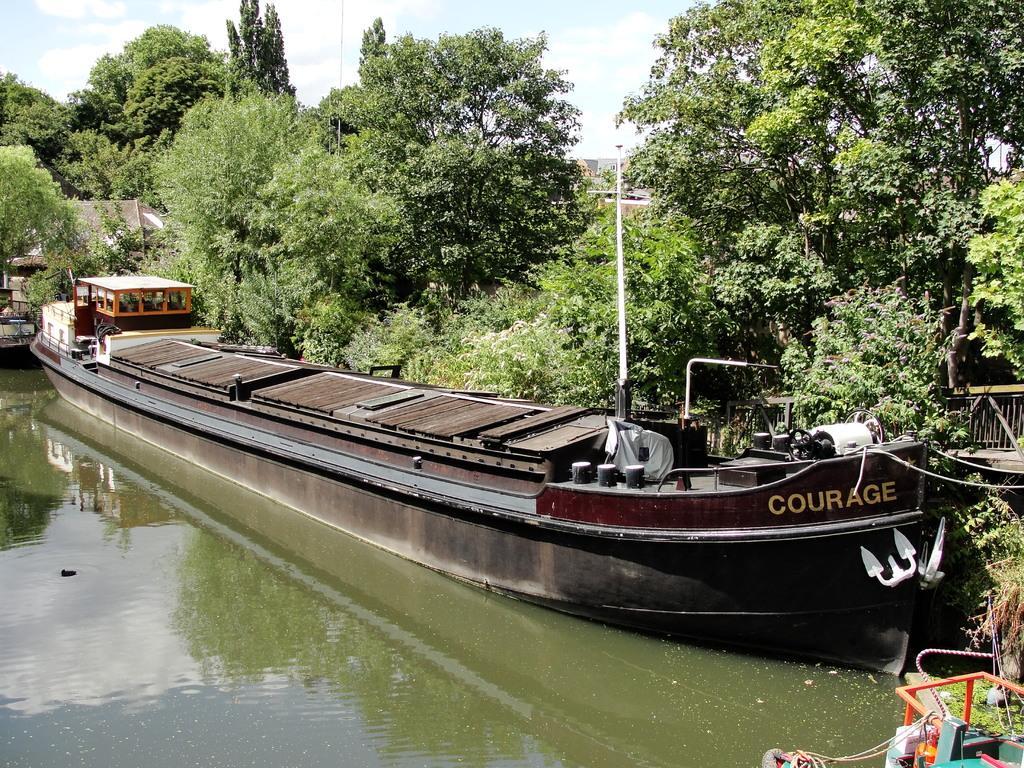Please provide a concise description of this image. In this image we can see boats on the water. In the background there are trees and sky. 